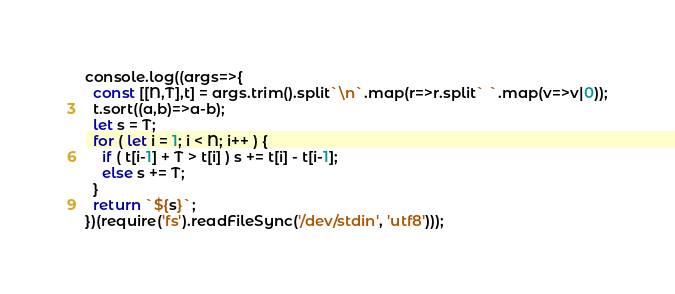Convert code to text. <code><loc_0><loc_0><loc_500><loc_500><_JavaScript_>console.log((args=>{
  const [[N,T],t] = args.trim().split`\n`.map(r=>r.split` `.map(v=>v|0));
  t.sort((a,b)=>a-b);
  let s = T;
  for ( let i = 1; i < N; i++ ) {
    if ( t[i-1] + T > t[i] ) s += t[i] - t[i-1];
    else s += T;
  }
  return `${s}`;
})(require('fs').readFileSync('/dev/stdin', 'utf8')));
</code> 